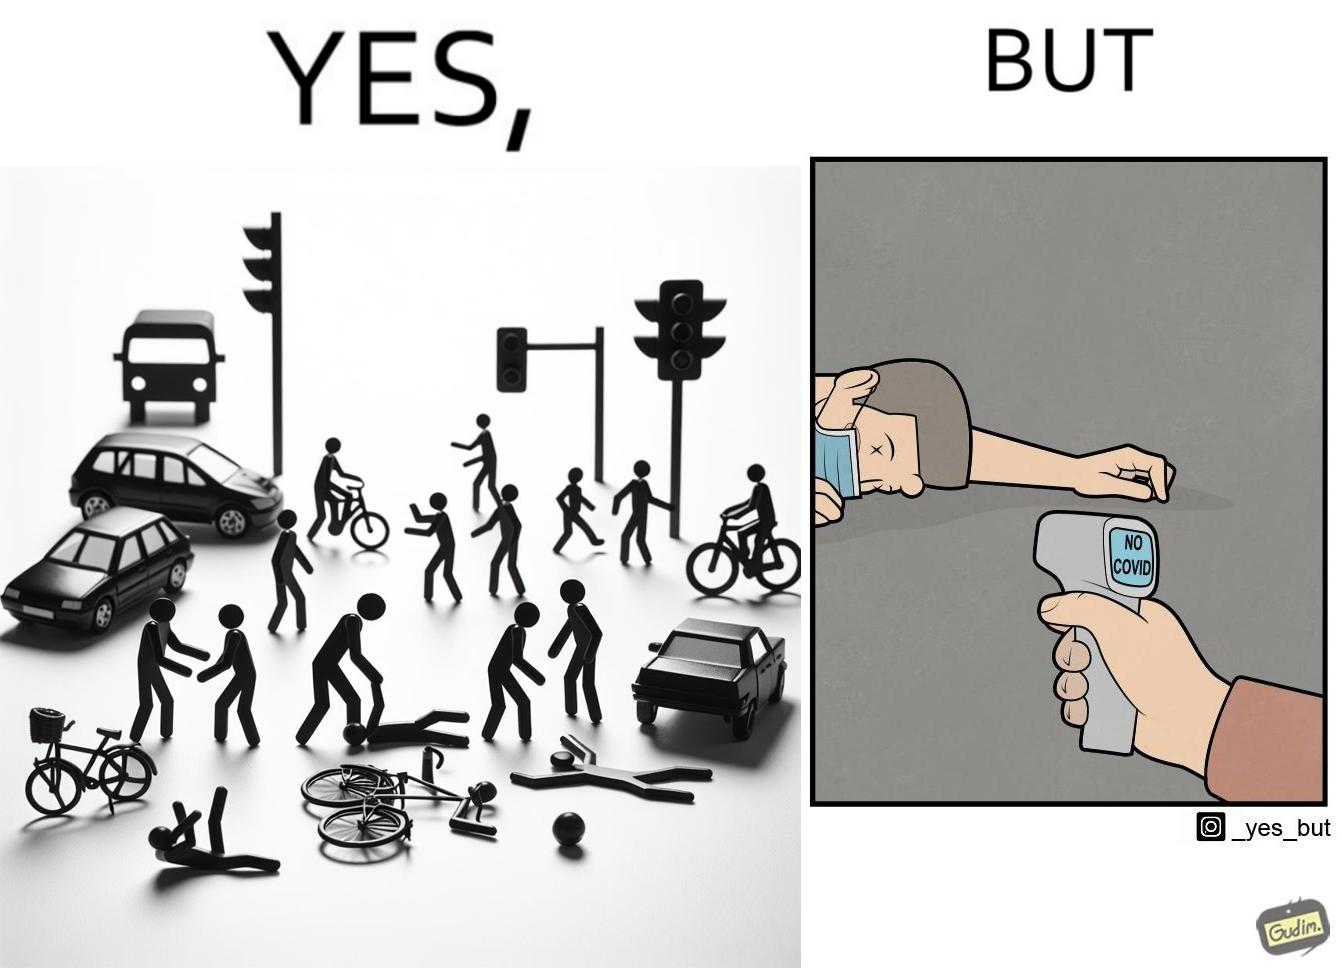Describe the satirical element in this image. the irony in the image comes from people trying to avoid covid, where a injured person is scanned for covid before they get help. 